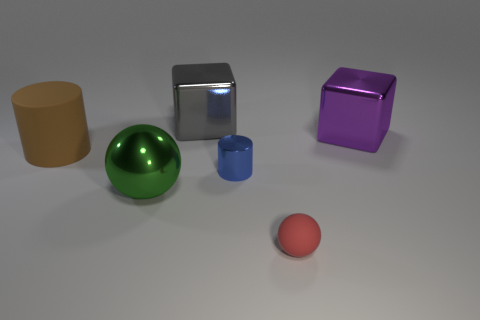How many large purple blocks are there?
Keep it short and to the point. 1. Does the cylinder right of the matte cylinder have the same size as the small rubber ball?
Offer a terse response. Yes. What number of rubber things are either purple cubes or big gray objects?
Ensure brevity in your answer.  0. What number of large green things are behind the object that is behind the purple thing?
Provide a succinct answer. 0. The metallic object that is to the right of the big green metal ball and in front of the large cylinder has what shape?
Make the answer very short. Cylinder. The large cylinder that is behind the cylinder to the right of the block that is on the left side of the rubber sphere is made of what material?
Keep it short and to the point. Rubber. What is the material of the big brown cylinder?
Offer a very short reply. Rubber. Is the tiny cylinder made of the same material as the big thing in front of the big brown object?
Make the answer very short. Yes. There is a large object to the right of the big metal cube that is behind the big purple object; what is its color?
Provide a short and direct response. Purple. How big is the object that is both on the right side of the small metal object and in front of the large brown rubber object?
Offer a very short reply. Small. 